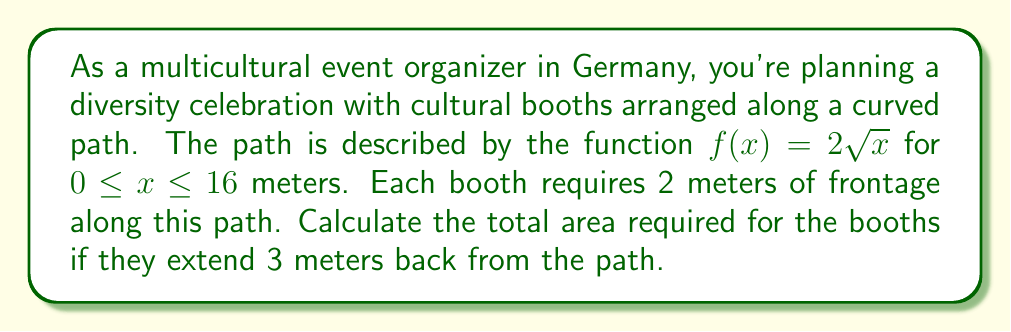Could you help me with this problem? To solve this problem, we need to use integration to find the area of the curved strip. Let's break it down step by step:

1) The area of the curved strip can be found using the arc length formula:

   $A = \int_{0}^{16} 3 \sqrt{1 + [f'(x)]^2} dx$

   where 3 is the width of the booths.

2) First, let's find $f'(x)$:
   
   $f(x) = 2\sqrt{x}$
   $f'(x) = \frac{1}{\sqrt{x}}$

3) Now, let's substitute this into our integral:

   $A = 3 \int_{0}^{16} \sqrt{1 + (\frac{1}{\sqrt{x}})^2} dx$

4) Simplify under the square root:

   $A = 3 \int_{0}^{16} \sqrt{1 + \frac{1}{x}} dx$

5) This integral is not easily solvable by elementary methods. We can use the substitution $u = \sqrt{x}$ to simplify it:

   $x = u^2$
   $dx = 2u du$
   When $x = 0$, $u = 0$
   When $x = 16$, $u = 4$

6) Substituting:

   $A = 3 \int_{0}^{4} \sqrt{1 + \frac{1}{u^2}} \cdot 2u du$
   $A = 6 \int_{0}^{4} \sqrt{u^2 + 1} du$

7) This is now in the form of $\int \sqrt{u^2 + 1} du$, which has the solution:

   $\frac{1}{2}(u\sqrt{u^2+1} + \ln|u + \sqrt{u^2+1}|) + C$

8) Applying the limits:

   $A = 6 [\frac{1}{2}(u\sqrt{u^2+1} + \ln|u + \sqrt{u^2+1}|)]_{0}^{4}$

9) Evaluating:

   $A = 6 [\frac{1}{2}(4\sqrt{17} + \ln|4 + \sqrt{17}|) - \frac{1}{2}(0 + \ln|0 + 1|)]$
   $A = 3(4\sqrt{17} + \ln|4 + \sqrt{17}|)$

10) This can be approximated to:

    $A \approx 3(16.49 + 2.83) \approx 57.96$ square meters
Answer: The total area required for the booths is approximately 57.96 square meters. 